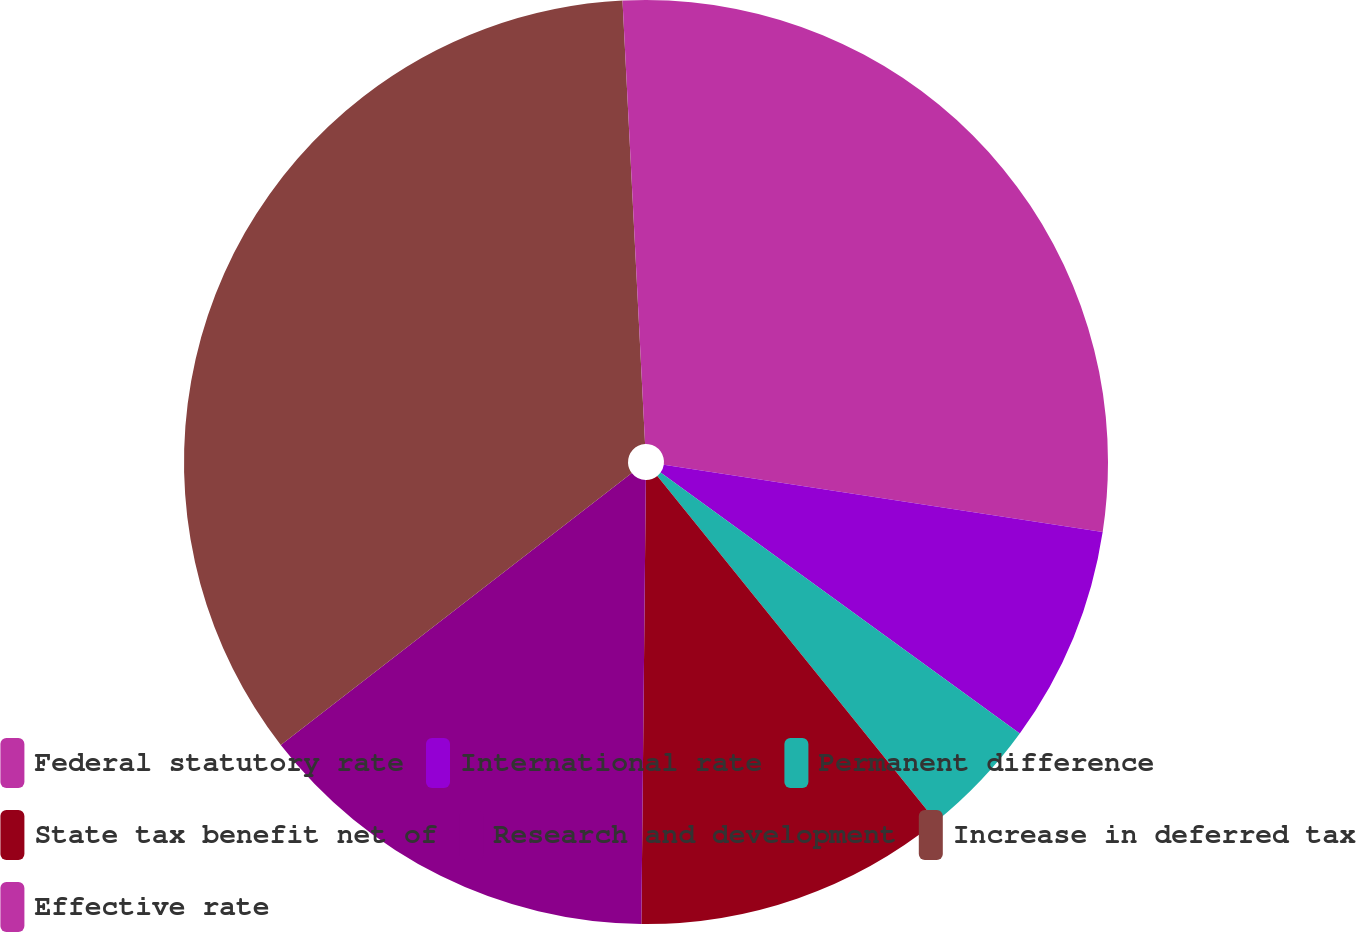<chart> <loc_0><loc_0><loc_500><loc_500><pie_chart><fcel>Federal statutory rate<fcel>International rate<fcel>Permanent difference<fcel>State tax benefit net of<fcel>Research and development<fcel>Increase in deferred tax<fcel>Effective rate<nl><fcel>27.42%<fcel>7.58%<fcel>4.19%<fcel>10.97%<fcel>14.35%<fcel>34.68%<fcel>0.81%<nl></chart> 